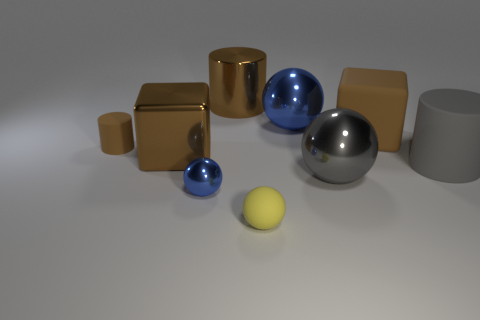Subtract all brown cylinders. How many cylinders are left? 1 Subtract all brown cylinders. How many cylinders are left? 1 Subtract 2 spheres. How many spheres are left? 2 Subtract all cubes. How many objects are left? 7 Subtract all green balls. Subtract all purple blocks. How many balls are left? 4 Subtract all blue balls. How many yellow cylinders are left? 0 Subtract all big yellow matte spheres. Subtract all small yellow rubber things. How many objects are left? 8 Add 8 rubber cylinders. How many rubber cylinders are left? 10 Add 8 big gray spheres. How many big gray spheres exist? 9 Subtract 0 yellow cubes. How many objects are left? 9 